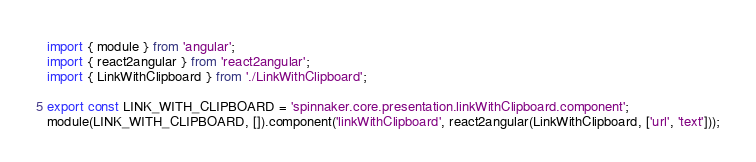Convert code to text. <code><loc_0><loc_0><loc_500><loc_500><_TypeScript_>import { module } from 'angular';
import { react2angular } from 'react2angular';
import { LinkWithClipboard } from './LinkWithClipboard';

export const LINK_WITH_CLIPBOARD = 'spinnaker.core.presentation.linkWithClipboard.component';
module(LINK_WITH_CLIPBOARD, []).component('linkWithClipboard', react2angular(LinkWithClipboard, ['url', 'text']));
</code> 